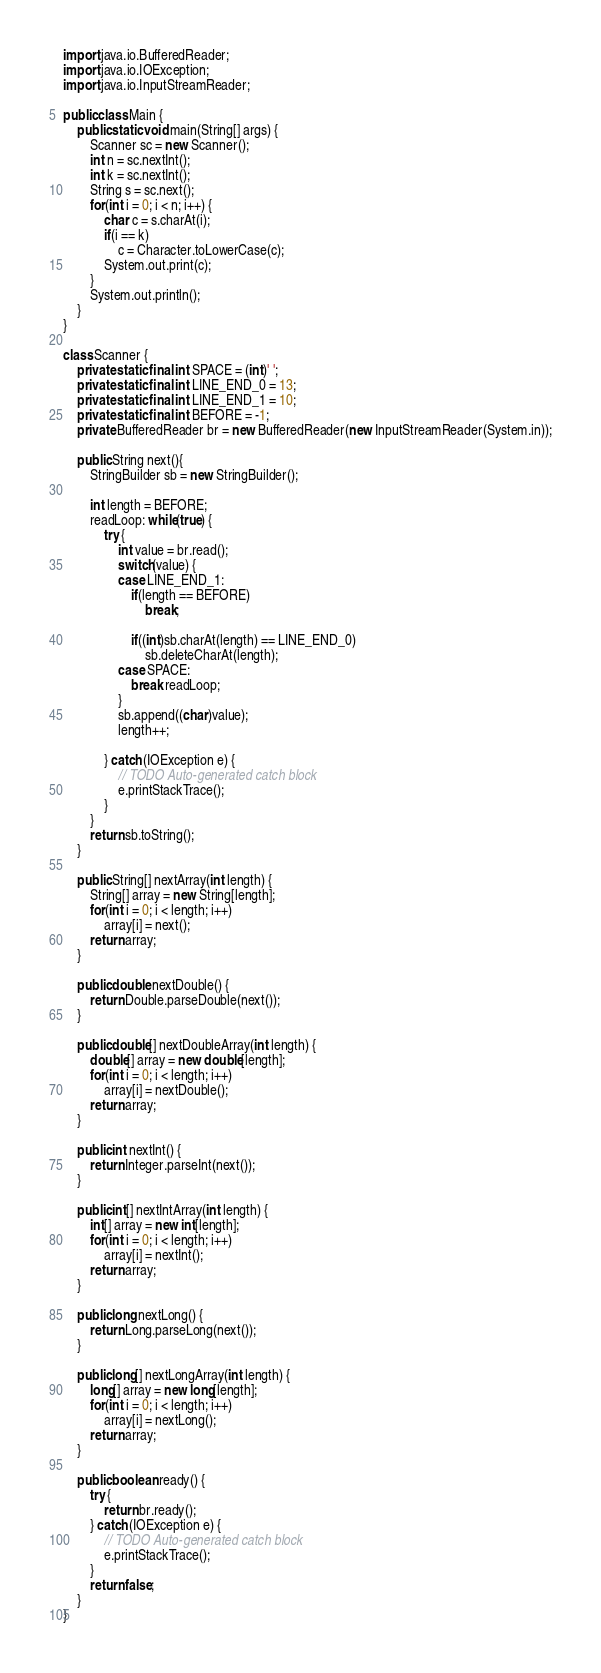<code> <loc_0><loc_0><loc_500><loc_500><_Java_>
import java.io.BufferedReader;
import java.io.IOException;
import java.io.InputStreamReader;

public class Main {
	public static void main(String[] args) {
		Scanner sc = new Scanner();
		int n = sc.nextInt();
		int k = sc.nextInt();
		String s = sc.next();
		for(int i = 0; i < n; i++) {
			char c = s.charAt(i);
			if(i == k)
				c = Character.toLowerCase(c);
			System.out.print(c);
		}
		System.out.println();
	}
}

class Scanner {
	private static final int SPACE = (int)' ';
	private static final int LINE_END_0 = 13;
	private static final int LINE_END_1 = 10;
	private static final int BEFORE = -1;
	private BufferedReader br = new BufferedReader(new InputStreamReader(System.in));
	
	public String next(){
		StringBuilder sb = new StringBuilder();
		
		int length = BEFORE;
		readLoop: while(true) {
			try {
				int value = br.read();
				switch(value) {
				case LINE_END_1:
					if(length == BEFORE)
						break;
					
					if((int)sb.charAt(length) == LINE_END_0)
						sb.deleteCharAt(length);
				case SPACE:
					break readLoop;
				}
				sb.append((char)value);
				length++;

			} catch (IOException e) {
				// TODO Auto-generated catch block
				e.printStackTrace();
			}
		}
		return sb.toString();
	}
	
	public String[] nextArray(int length) {
		String[] array = new String[length];
		for(int i = 0; i < length; i++)
			array[i] = next();
		return array;
	}
	
	public double nextDouble() {
		return Double.parseDouble(next());
	}
	
	public double[] nextDoubleArray(int length) {
		double[] array = new double[length];
		for(int i = 0; i < length; i++)
			array[i] = nextDouble();
		return array;
	}
	
	public int nextInt() {
		return Integer.parseInt(next());
	}
	
	public int[] nextIntArray(int length) {
		int[] array = new int[length];
		for(int i = 0; i < length; i++)
			array[i] = nextInt();
		return array;
	}
	
	public long nextLong() {
		return Long.parseLong(next());
	}
	
	public long[] nextLongArray(int length) {
		long[] array = new long[length];
		for(int i = 0; i < length; i++)
			array[i] = nextLong();
		return array;
	}
	
	public boolean ready() {
		try {
			return br.ready();
		} catch (IOException e) {
			// TODO Auto-generated catch block
			e.printStackTrace();
		}
		return false;
	}
}
</code> 